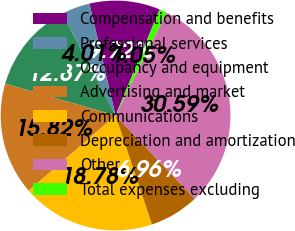Convert chart to OTSL. <chart><loc_0><loc_0><loc_500><loc_500><pie_chart><fcel>Compensation and benefits<fcel>Professional services<fcel>Occupancy and equipment<fcel>Advertising and market<fcel>Communications<fcel>Depreciation and amortization<fcel>Other<fcel>Total expenses excluding<nl><fcel>9.92%<fcel>4.01%<fcel>12.87%<fcel>15.82%<fcel>18.78%<fcel>6.96%<fcel>30.59%<fcel>1.05%<nl></chart> 